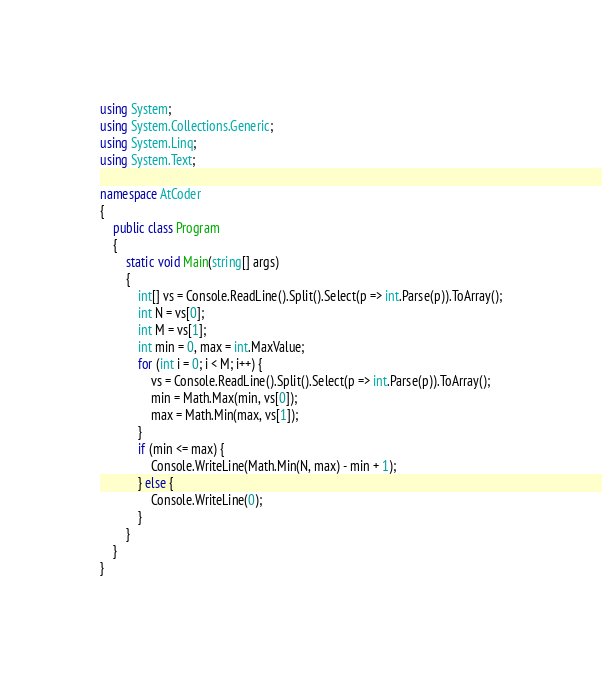Convert code to text. <code><loc_0><loc_0><loc_500><loc_500><_C#_>using System;
using System.Collections.Generic;
using System.Linq;
using System.Text;

namespace AtCoder
{
	public class Program
	{
		static void Main(string[] args)
		{
			int[] vs = Console.ReadLine().Split().Select(p => int.Parse(p)).ToArray();
			int N = vs[0];
			int M = vs[1];
			int min = 0, max = int.MaxValue;
			for (int i = 0; i < M; i++) {
				vs = Console.ReadLine().Split().Select(p => int.Parse(p)).ToArray();
				min = Math.Max(min, vs[0]);
				max = Math.Min(max, vs[1]);
			}
			if (min <= max) {
				Console.WriteLine(Math.Min(N, max) - min + 1);
			} else {
				Console.WriteLine(0);
			}
		}
	}
}
</code> 